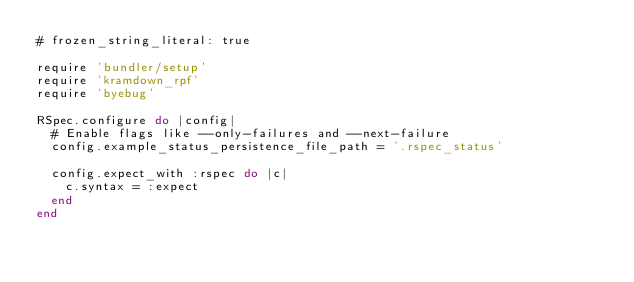Convert code to text. <code><loc_0><loc_0><loc_500><loc_500><_Ruby_># frozen_string_literal: true

require 'bundler/setup'
require 'kramdown_rpf'
require 'byebug'

RSpec.configure do |config|
  # Enable flags like --only-failures and --next-failure
  config.example_status_persistence_file_path = '.rspec_status'

  config.expect_with :rspec do |c|
    c.syntax = :expect
  end
end
</code> 